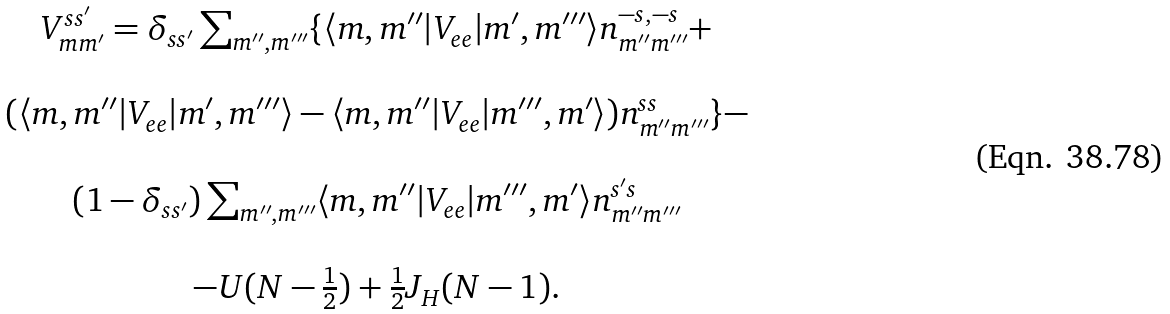<formula> <loc_0><loc_0><loc_500><loc_500>\begin{array} { c } V _ { m m ^ { \prime } } ^ { s s ^ { \prime } } = \delta _ { s s ^ { \prime } } \sum _ { m ^ { \prime \prime } , m ^ { \prime \prime \prime } } \{ \langle m , m ^ { \prime \prime } | V _ { e e } | m ^ { \prime } , m ^ { \prime \prime \prime } \rangle n _ { m ^ { \prime \prime } m ^ { \prime \prime \prime } } ^ { - s , - s } + \\ \\ ( \langle m , m ^ { \prime \prime } | V _ { e e } | m ^ { \prime } , m ^ { \prime \prime \prime } \rangle - \langle m , m ^ { \prime \prime } | V _ { e e } | m ^ { \prime \prime \prime } , m ^ { \prime } \rangle ) n _ { m ^ { \prime \prime } m ^ { \prime \prime \prime } } ^ { s s } \} - \\ \\ \left ( 1 - \delta _ { s s ^ { \prime } } \right ) \sum _ { m ^ { \prime \prime } , m ^ { \prime \prime \prime } } \langle m , m ^ { \prime \prime } | V _ { e e } | m ^ { \prime \prime \prime } , m ^ { \prime } \rangle n _ { m ^ { \prime \prime } m ^ { \prime \prime \prime } } ^ { s ^ { \prime } s } \\ \\ - U ( N - \frac { 1 } { 2 } ) + \frac { 1 } { 2 } J _ { H } ( N - 1 ) . \end{array}</formula> 